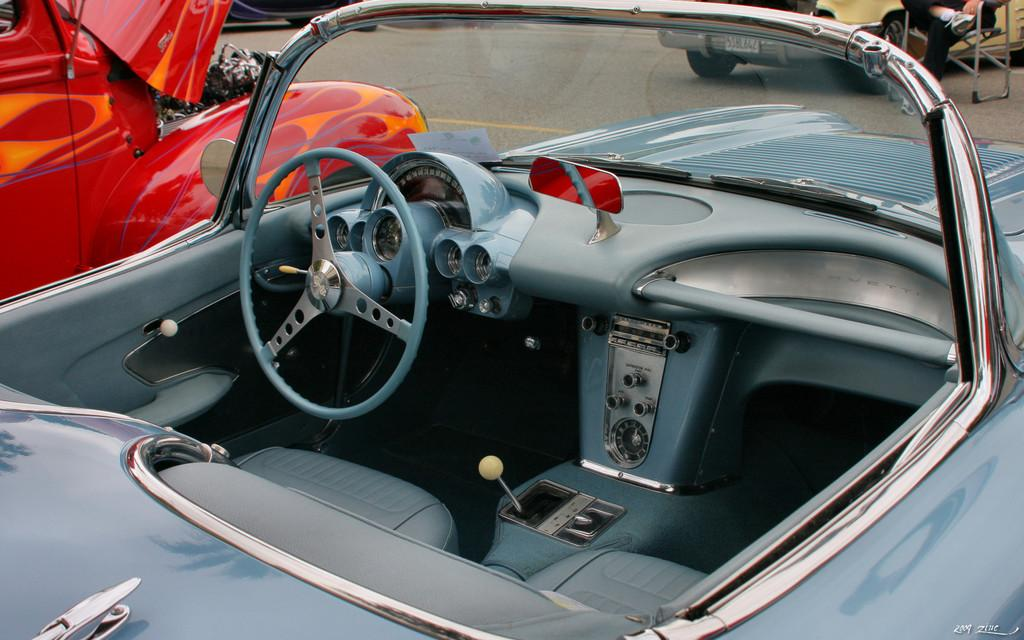What is the main subject in the foreground of the image? There is a car in the foreground of the image. How many cars can be seen in the image? There are two cars visible in the image. Can you describe the person in the image? There is a person sitting on a chair in the image. What type of necklace is the person wearing in the image? There is no necklace visible in the image; the person is sitting on a chair. 